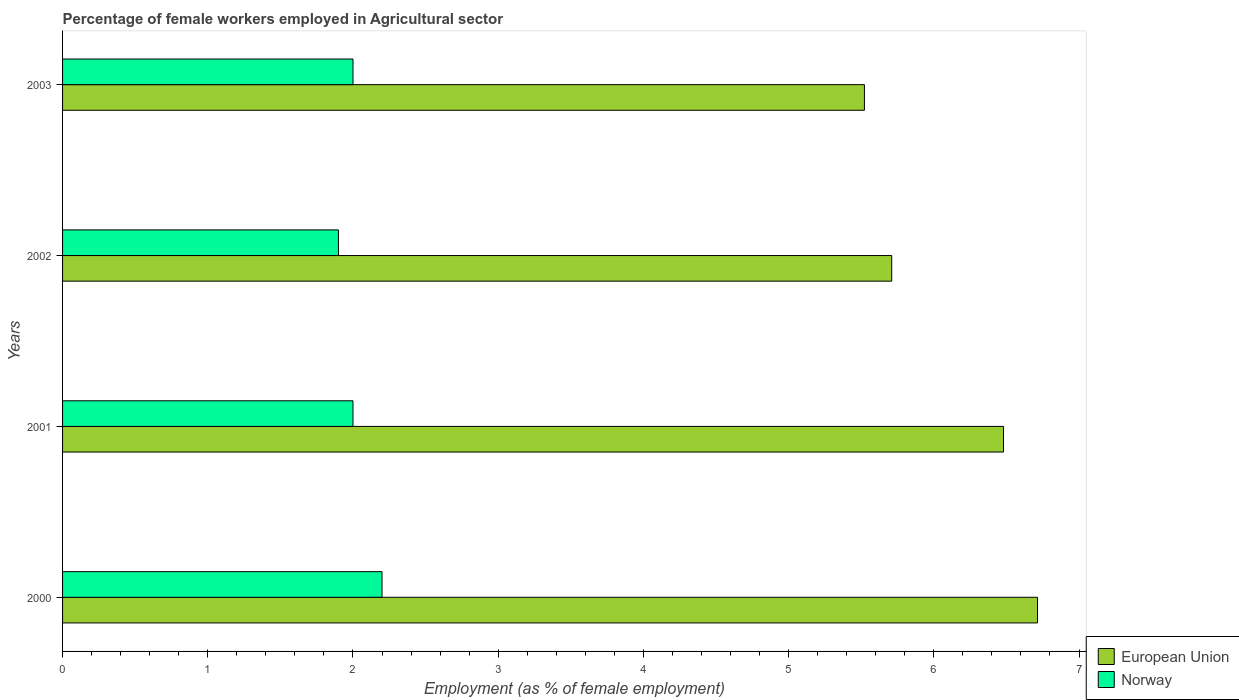How many groups of bars are there?
Provide a short and direct response. 4. How many bars are there on the 4th tick from the top?
Offer a very short reply. 2. In how many cases, is the number of bars for a given year not equal to the number of legend labels?
Your answer should be very brief. 0. What is the percentage of females employed in Agricultural sector in European Union in 2000?
Provide a short and direct response. 6.71. Across all years, what is the maximum percentage of females employed in Agricultural sector in Norway?
Your response must be concise. 2.2. Across all years, what is the minimum percentage of females employed in Agricultural sector in European Union?
Keep it short and to the point. 5.52. What is the total percentage of females employed in Agricultural sector in European Union in the graph?
Provide a succinct answer. 24.43. What is the difference between the percentage of females employed in Agricultural sector in European Union in 2000 and that in 2001?
Ensure brevity in your answer.  0.23. What is the difference between the percentage of females employed in Agricultural sector in Norway in 2000 and the percentage of females employed in Agricultural sector in European Union in 2003?
Provide a short and direct response. -3.32. What is the average percentage of females employed in Agricultural sector in Norway per year?
Give a very brief answer. 2.03. In the year 2002, what is the difference between the percentage of females employed in Agricultural sector in Norway and percentage of females employed in Agricultural sector in European Union?
Keep it short and to the point. -3.81. What is the ratio of the percentage of females employed in Agricultural sector in Norway in 2000 to that in 2003?
Provide a succinct answer. 1.1. Is the difference between the percentage of females employed in Agricultural sector in Norway in 2000 and 2002 greater than the difference between the percentage of females employed in Agricultural sector in European Union in 2000 and 2002?
Offer a very short reply. No. What is the difference between the highest and the second highest percentage of females employed in Agricultural sector in Norway?
Your answer should be very brief. 0.2. What is the difference between the highest and the lowest percentage of females employed in Agricultural sector in European Union?
Give a very brief answer. 1.19. Is the sum of the percentage of females employed in Agricultural sector in Norway in 2001 and 2003 greater than the maximum percentage of females employed in Agricultural sector in European Union across all years?
Provide a succinct answer. No. What does the 2nd bar from the top in 2001 represents?
Your response must be concise. European Union. How many bars are there?
Your answer should be very brief. 8. Are all the bars in the graph horizontal?
Provide a short and direct response. Yes. How many years are there in the graph?
Your response must be concise. 4. What is the difference between two consecutive major ticks on the X-axis?
Your answer should be compact. 1. Are the values on the major ticks of X-axis written in scientific E-notation?
Provide a short and direct response. No. Does the graph contain any zero values?
Keep it short and to the point. No. Does the graph contain grids?
Provide a succinct answer. No. What is the title of the graph?
Provide a short and direct response. Percentage of female workers employed in Agricultural sector. What is the label or title of the X-axis?
Provide a short and direct response. Employment (as % of female employment). What is the label or title of the Y-axis?
Offer a very short reply. Years. What is the Employment (as % of female employment) in European Union in 2000?
Ensure brevity in your answer.  6.71. What is the Employment (as % of female employment) in Norway in 2000?
Your answer should be compact. 2.2. What is the Employment (as % of female employment) in European Union in 2001?
Make the answer very short. 6.48. What is the Employment (as % of female employment) of Norway in 2001?
Offer a very short reply. 2. What is the Employment (as % of female employment) of European Union in 2002?
Keep it short and to the point. 5.71. What is the Employment (as % of female employment) in Norway in 2002?
Keep it short and to the point. 1.9. What is the Employment (as % of female employment) in European Union in 2003?
Make the answer very short. 5.52. Across all years, what is the maximum Employment (as % of female employment) in European Union?
Offer a terse response. 6.71. Across all years, what is the maximum Employment (as % of female employment) in Norway?
Ensure brevity in your answer.  2.2. Across all years, what is the minimum Employment (as % of female employment) in European Union?
Your answer should be very brief. 5.52. Across all years, what is the minimum Employment (as % of female employment) in Norway?
Offer a terse response. 1.9. What is the total Employment (as % of female employment) of European Union in the graph?
Offer a very short reply. 24.43. What is the total Employment (as % of female employment) in Norway in the graph?
Ensure brevity in your answer.  8.1. What is the difference between the Employment (as % of female employment) in European Union in 2000 and that in 2001?
Offer a very short reply. 0.23. What is the difference between the Employment (as % of female employment) of Norway in 2000 and that in 2001?
Your answer should be very brief. 0.2. What is the difference between the Employment (as % of female employment) of European Union in 2000 and that in 2002?
Your response must be concise. 1. What is the difference between the Employment (as % of female employment) in Norway in 2000 and that in 2002?
Your answer should be compact. 0.3. What is the difference between the Employment (as % of female employment) of European Union in 2000 and that in 2003?
Offer a very short reply. 1.19. What is the difference between the Employment (as % of female employment) in Norway in 2000 and that in 2003?
Keep it short and to the point. 0.2. What is the difference between the Employment (as % of female employment) in European Union in 2001 and that in 2002?
Your answer should be compact. 0.77. What is the difference between the Employment (as % of female employment) in Norway in 2001 and that in 2002?
Provide a succinct answer. 0.1. What is the difference between the Employment (as % of female employment) of European Union in 2001 and that in 2003?
Offer a very short reply. 0.96. What is the difference between the Employment (as % of female employment) in Norway in 2001 and that in 2003?
Offer a terse response. 0. What is the difference between the Employment (as % of female employment) in European Union in 2002 and that in 2003?
Your response must be concise. 0.19. What is the difference between the Employment (as % of female employment) in European Union in 2000 and the Employment (as % of female employment) in Norway in 2001?
Provide a succinct answer. 4.71. What is the difference between the Employment (as % of female employment) of European Union in 2000 and the Employment (as % of female employment) of Norway in 2002?
Make the answer very short. 4.81. What is the difference between the Employment (as % of female employment) of European Union in 2000 and the Employment (as % of female employment) of Norway in 2003?
Provide a succinct answer. 4.71. What is the difference between the Employment (as % of female employment) of European Union in 2001 and the Employment (as % of female employment) of Norway in 2002?
Ensure brevity in your answer.  4.58. What is the difference between the Employment (as % of female employment) in European Union in 2001 and the Employment (as % of female employment) in Norway in 2003?
Your answer should be compact. 4.48. What is the difference between the Employment (as % of female employment) in European Union in 2002 and the Employment (as % of female employment) in Norway in 2003?
Ensure brevity in your answer.  3.71. What is the average Employment (as % of female employment) of European Union per year?
Offer a very short reply. 6.11. What is the average Employment (as % of female employment) in Norway per year?
Offer a terse response. 2.02. In the year 2000, what is the difference between the Employment (as % of female employment) of European Union and Employment (as % of female employment) of Norway?
Offer a terse response. 4.51. In the year 2001, what is the difference between the Employment (as % of female employment) in European Union and Employment (as % of female employment) in Norway?
Provide a short and direct response. 4.48. In the year 2002, what is the difference between the Employment (as % of female employment) of European Union and Employment (as % of female employment) of Norway?
Make the answer very short. 3.81. In the year 2003, what is the difference between the Employment (as % of female employment) in European Union and Employment (as % of female employment) in Norway?
Offer a terse response. 3.52. What is the ratio of the Employment (as % of female employment) of European Union in 2000 to that in 2001?
Your response must be concise. 1.04. What is the ratio of the Employment (as % of female employment) of Norway in 2000 to that in 2001?
Keep it short and to the point. 1.1. What is the ratio of the Employment (as % of female employment) in European Union in 2000 to that in 2002?
Offer a terse response. 1.18. What is the ratio of the Employment (as % of female employment) in Norway in 2000 to that in 2002?
Your answer should be very brief. 1.16. What is the ratio of the Employment (as % of female employment) of European Union in 2000 to that in 2003?
Provide a short and direct response. 1.22. What is the ratio of the Employment (as % of female employment) of Norway in 2000 to that in 2003?
Provide a short and direct response. 1.1. What is the ratio of the Employment (as % of female employment) in European Union in 2001 to that in 2002?
Your answer should be compact. 1.13. What is the ratio of the Employment (as % of female employment) of Norway in 2001 to that in 2002?
Provide a short and direct response. 1.05. What is the ratio of the Employment (as % of female employment) of European Union in 2001 to that in 2003?
Your answer should be compact. 1.17. What is the ratio of the Employment (as % of female employment) of European Union in 2002 to that in 2003?
Offer a very short reply. 1.03. What is the ratio of the Employment (as % of female employment) in Norway in 2002 to that in 2003?
Your response must be concise. 0.95. What is the difference between the highest and the second highest Employment (as % of female employment) of European Union?
Your answer should be compact. 0.23. What is the difference between the highest and the lowest Employment (as % of female employment) of European Union?
Keep it short and to the point. 1.19. 